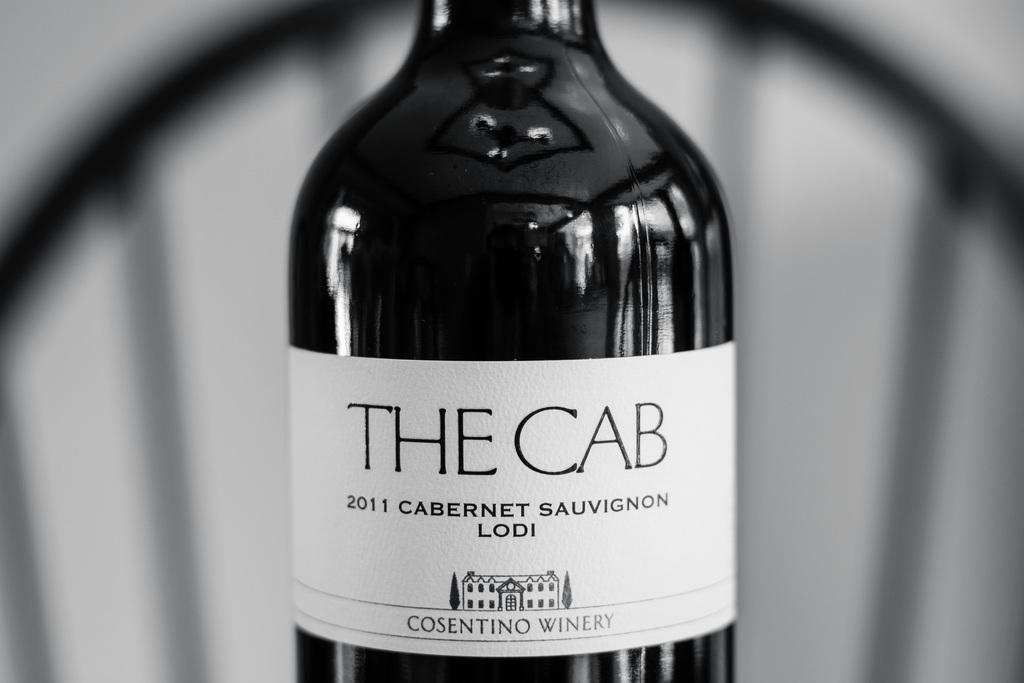<image>
Summarize the visual content of the image. the words the cab that are on a bottle 